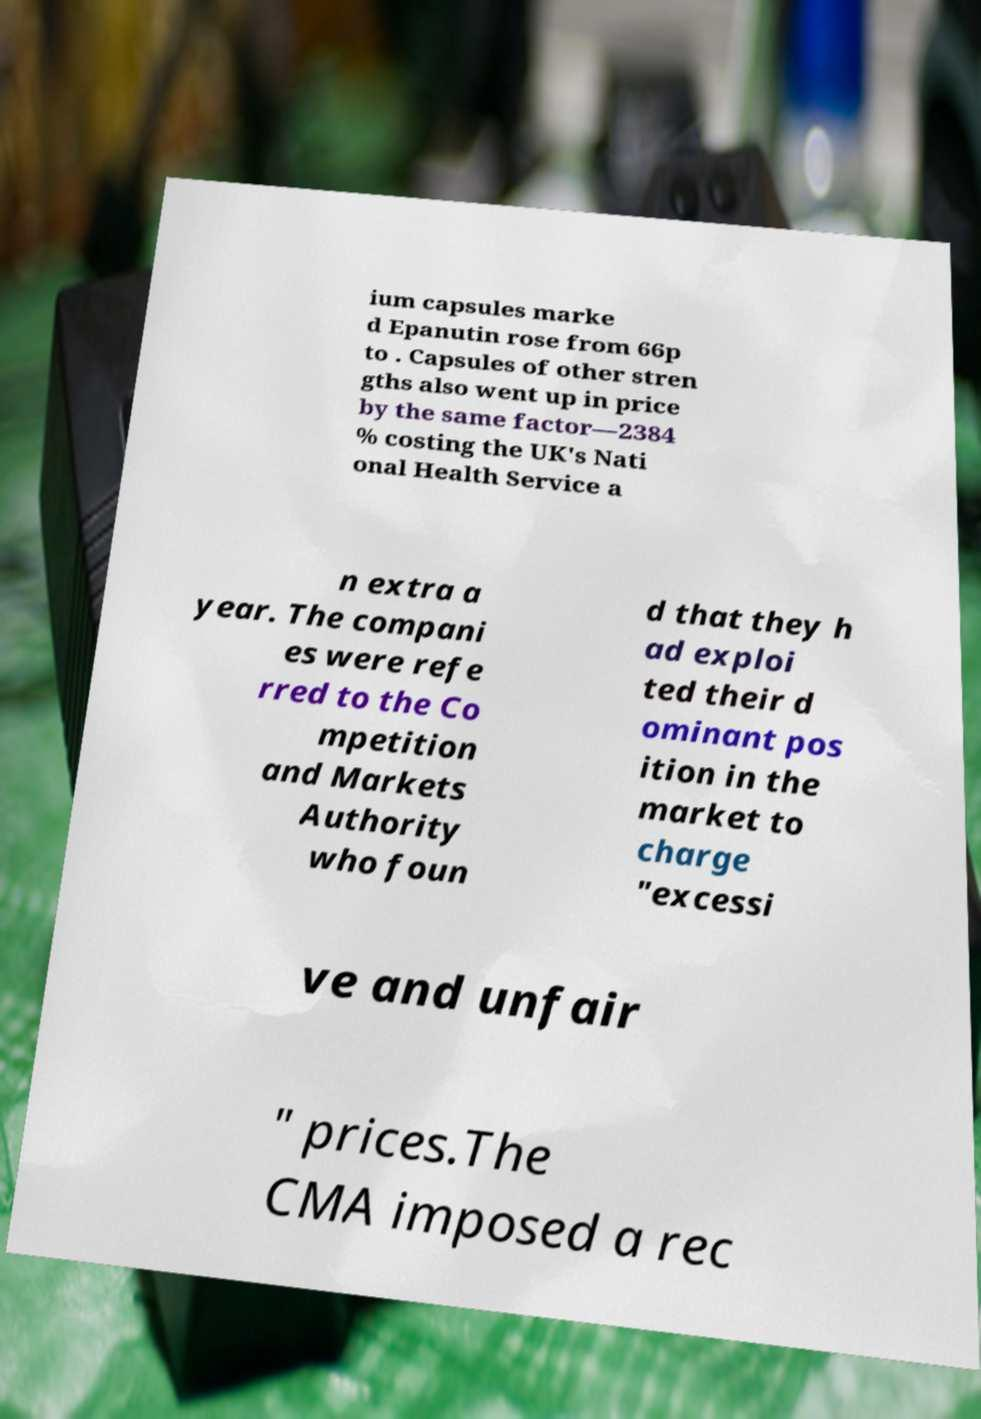Could you assist in decoding the text presented in this image and type it out clearly? ium capsules marke d Epanutin rose from 66p to . Capsules of other stren gths also went up in price by the same factor—2384 % costing the UK's Nati onal Health Service a n extra a year. The compani es were refe rred to the Co mpetition and Markets Authority who foun d that they h ad exploi ted their d ominant pos ition in the market to charge "excessi ve and unfair " prices.The CMA imposed a rec 